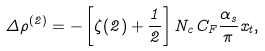Convert formula to latex. <formula><loc_0><loc_0><loc_500><loc_500>\Delta \rho ^ { ( 2 ) } = - \left [ \zeta ( 2 ) + \frac { 1 } { 2 } \right ] N _ { c } C _ { F } \frac { \alpha _ { s } } { \pi } x _ { t } ,</formula> 